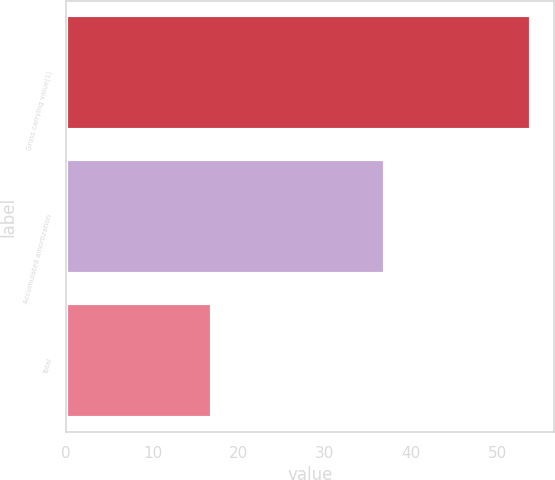Convert chart to OTSL. <chart><loc_0><loc_0><loc_500><loc_500><bar_chart><fcel>Gross carrying value(1)<fcel>Accumulated amortization<fcel>Total<nl><fcel>53.9<fcel>37<fcel>16.9<nl></chart> 